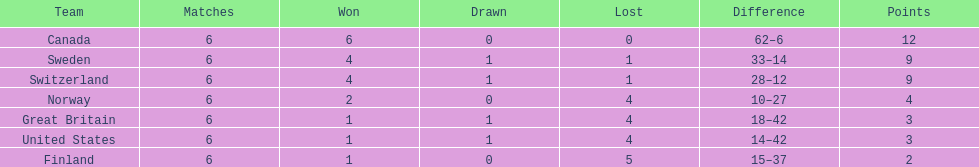What is the sum of teams having 4 complete wins? 2. 